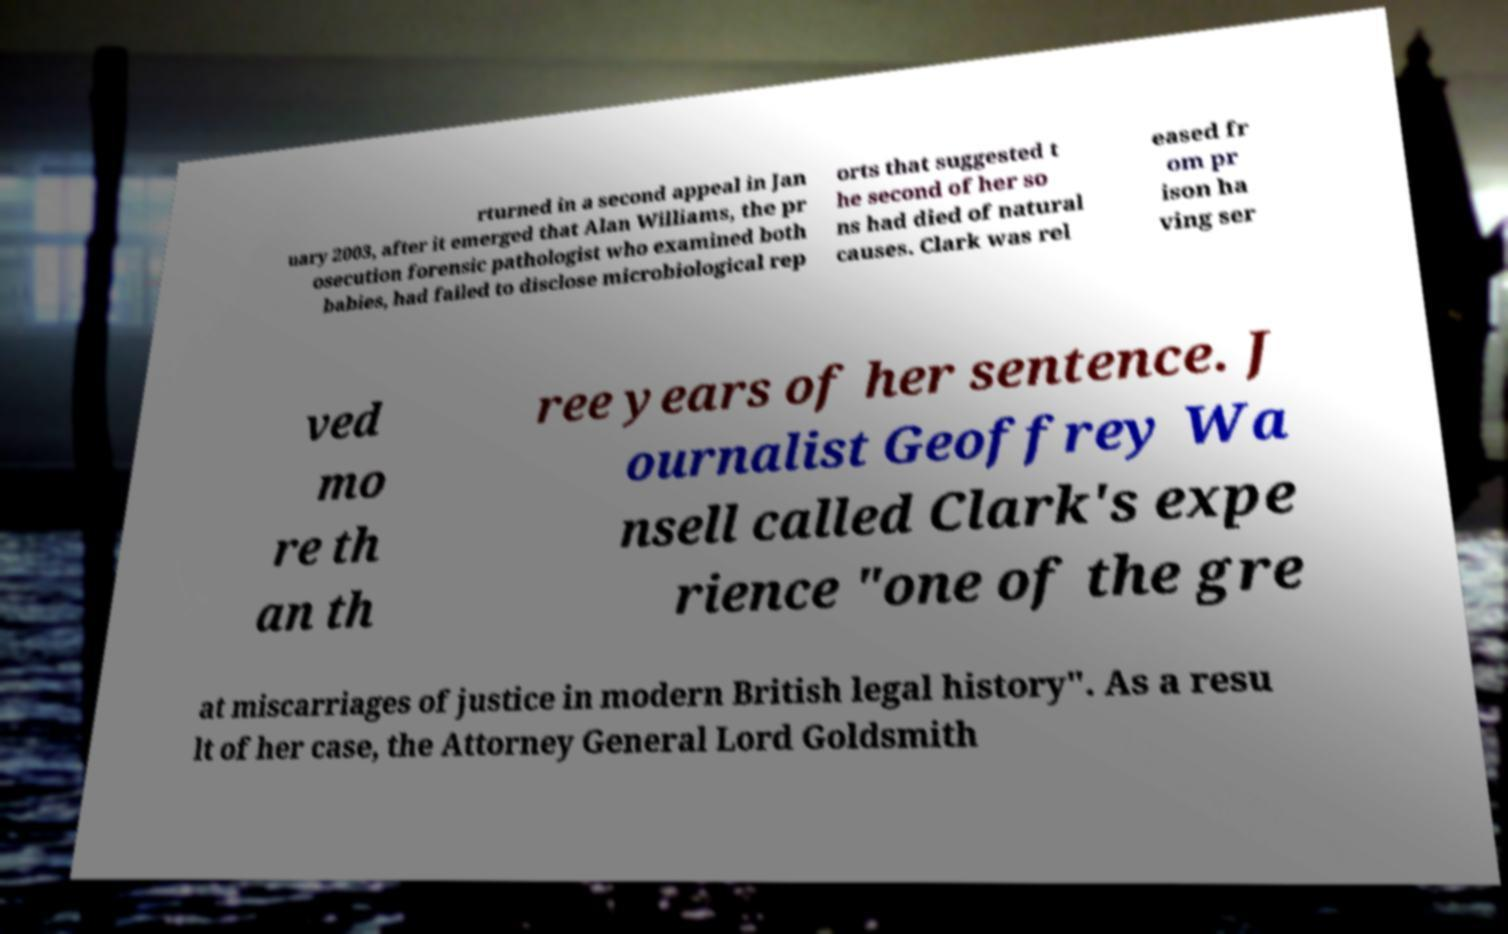For documentation purposes, I need the text within this image transcribed. Could you provide that? rturned in a second appeal in Jan uary 2003, after it emerged that Alan Williams, the pr osecution forensic pathologist who examined both babies, had failed to disclose microbiological rep orts that suggested t he second of her so ns had died of natural causes. Clark was rel eased fr om pr ison ha ving ser ved mo re th an th ree years of her sentence. J ournalist Geoffrey Wa nsell called Clark's expe rience "one of the gre at miscarriages of justice in modern British legal history". As a resu lt of her case, the Attorney General Lord Goldsmith 